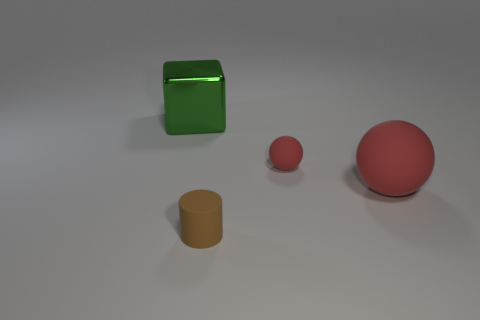Do the brown cylinder and the rubber object that is behind the big red object have the same size?
Your answer should be compact. Yes. There is a thing that is behind the large rubber ball and on the right side of the brown rubber object; what is its size?
Your response must be concise. Small. Is there a matte object that has the same color as the small sphere?
Provide a short and direct response. Yes. What is the color of the big thing in front of the large thing that is left of the small sphere?
Provide a short and direct response. Red. Is the number of green cubes right of the matte cylinder less than the number of small red rubber balls on the left side of the tiny red rubber thing?
Your answer should be very brief. No. Is the metallic cube the same size as the brown rubber object?
Offer a very short reply. No. There is a object that is left of the small red ball and in front of the small rubber sphere; what shape is it?
Your response must be concise. Cylinder. How many small red blocks are the same material as the large sphere?
Make the answer very short. 0. How many green metal cubes are in front of the thing on the left side of the brown object?
Your response must be concise. 0. What shape is the small rubber thing to the left of the red ball behind the large object that is in front of the big green block?
Offer a very short reply. Cylinder. 